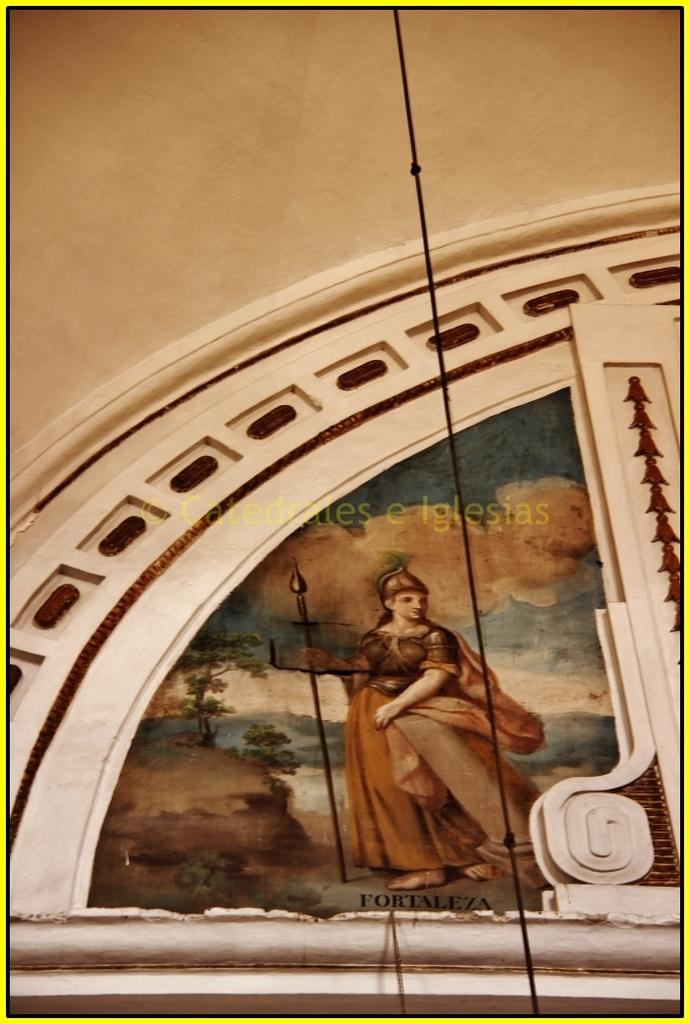What type of structure is visible in the image? There is a building in the image. Can you describe any additional features of the building? There is a photograph on the wall in the front of the building. What type of weather can be seen in the image? There is no weather visible in the image, as it focuses on the building and the photograph on the wall. Can you see a giraffe in the image? No, there is no giraffe present in the image. 